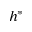Convert formula to latex. <formula><loc_0><loc_0><loc_500><loc_500>h ^ { * }</formula> 